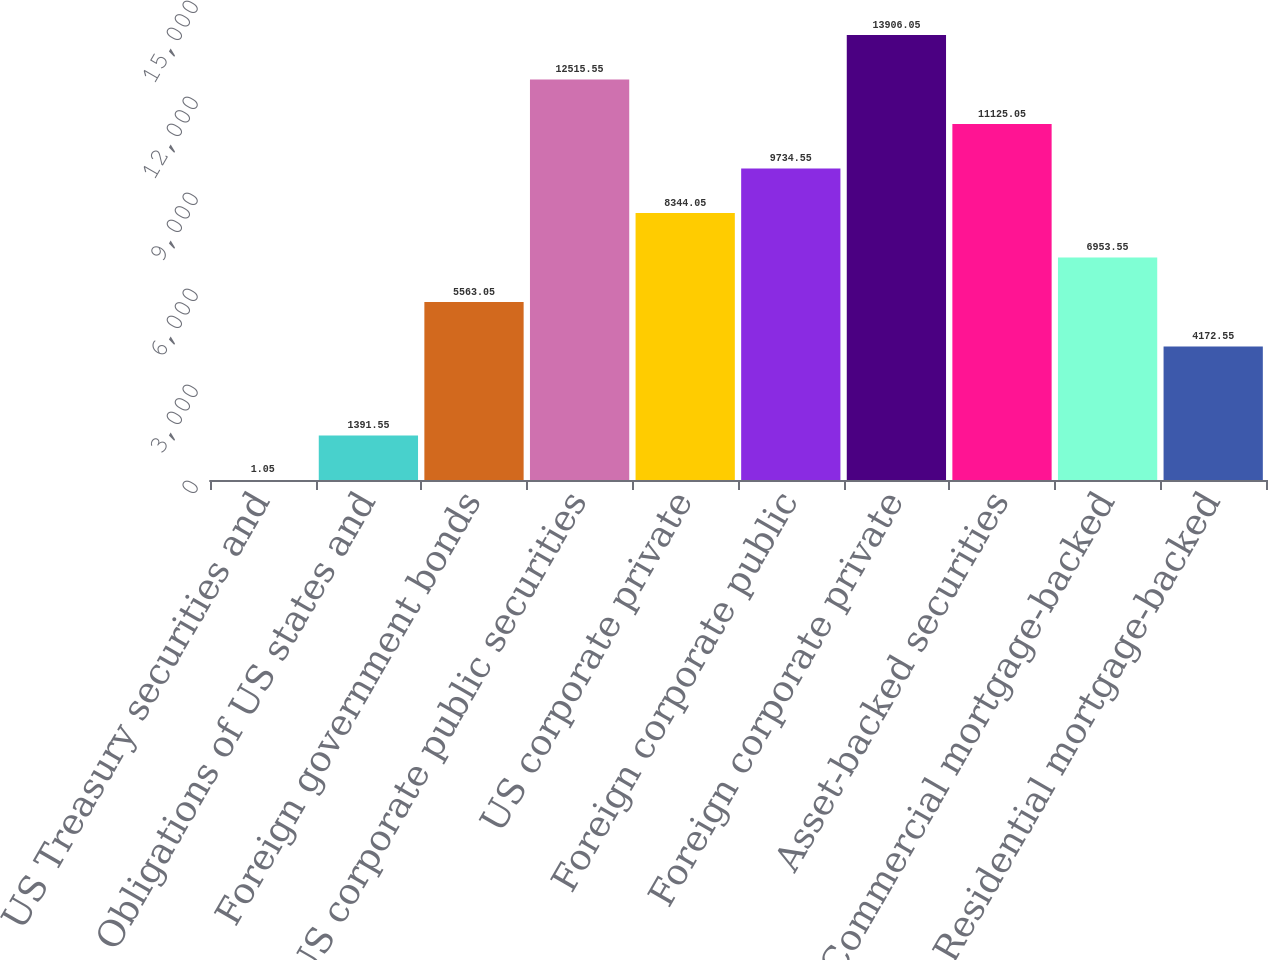Convert chart. <chart><loc_0><loc_0><loc_500><loc_500><bar_chart><fcel>US Treasury securities and<fcel>Obligations of US states and<fcel>Foreign government bonds<fcel>US corporate public securities<fcel>US corporate private<fcel>Foreign corporate public<fcel>Foreign corporate private<fcel>Asset-backed securities<fcel>Commercial mortgage-backed<fcel>Residential mortgage-backed<nl><fcel>1.05<fcel>1391.55<fcel>5563.05<fcel>12515.5<fcel>8344.05<fcel>9734.55<fcel>13906<fcel>11125<fcel>6953.55<fcel>4172.55<nl></chart> 